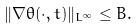<formula> <loc_0><loc_0><loc_500><loc_500>\| \nabla \theta ( \cdot , t ) \| _ { L ^ { \infty } } \leq B .</formula> 